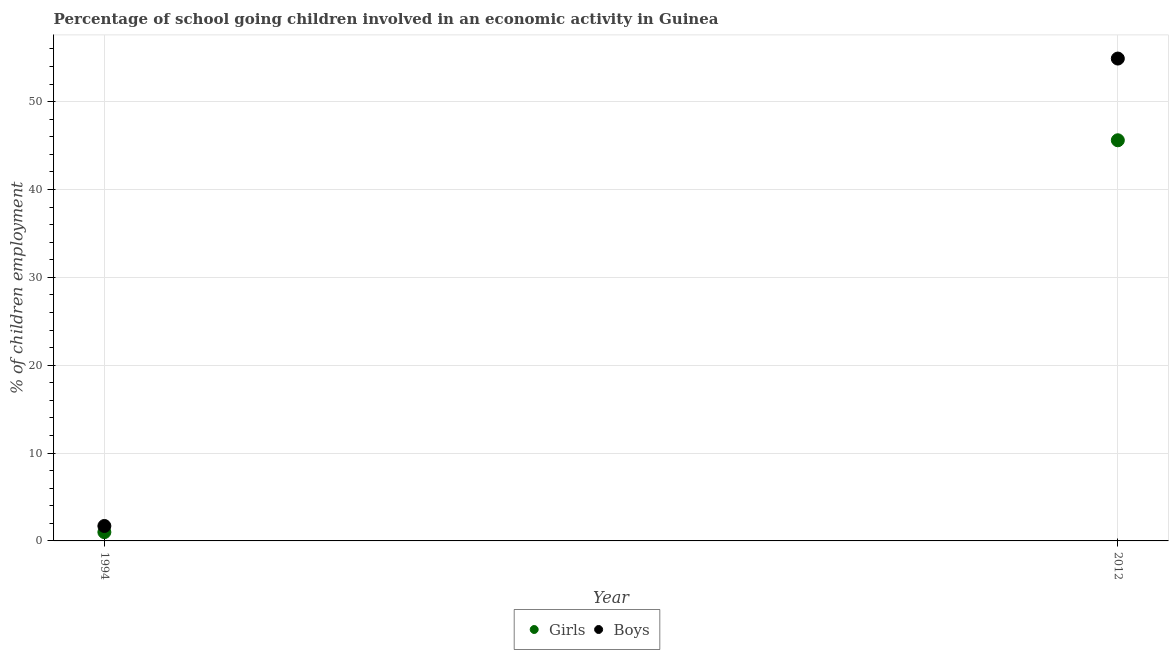What is the percentage of school going girls in 2012?
Provide a succinct answer. 45.6. Across all years, what is the maximum percentage of school going boys?
Offer a terse response. 54.9. In which year was the percentage of school going girls maximum?
Give a very brief answer. 2012. In which year was the percentage of school going girls minimum?
Your answer should be very brief. 1994. What is the total percentage of school going boys in the graph?
Your answer should be very brief. 56.6. What is the difference between the percentage of school going girls in 1994 and that in 2012?
Provide a short and direct response. -44.6. What is the difference between the percentage of school going girls in 1994 and the percentage of school going boys in 2012?
Keep it short and to the point. -53.9. What is the average percentage of school going boys per year?
Offer a very short reply. 28.3. In how many years, is the percentage of school going boys greater than 52 %?
Provide a succinct answer. 1. What is the ratio of the percentage of school going boys in 1994 to that in 2012?
Make the answer very short. 0.03. Is the percentage of school going girls in 1994 less than that in 2012?
Offer a very short reply. Yes. In how many years, is the percentage of school going boys greater than the average percentage of school going boys taken over all years?
Offer a terse response. 1. Does the percentage of school going girls monotonically increase over the years?
Ensure brevity in your answer.  Yes. Is the percentage of school going girls strictly less than the percentage of school going boys over the years?
Offer a very short reply. Yes. What is the difference between two consecutive major ticks on the Y-axis?
Provide a succinct answer. 10. Does the graph contain any zero values?
Make the answer very short. No. Where does the legend appear in the graph?
Your response must be concise. Bottom center. How many legend labels are there?
Give a very brief answer. 2. What is the title of the graph?
Ensure brevity in your answer.  Percentage of school going children involved in an economic activity in Guinea. What is the label or title of the Y-axis?
Provide a succinct answer. % of children employment. What is the % of children employment in Girls in 1994?
Your response must be concise. 1. What is the % of children employment in Boys in 1994?
Your answer should be compact. 1.7. What is the % of children employment in Girls in 2012?
Your response must be concise. 45.6. What is the % of children employment in Boys in 2012?
Your answer should be compact. 54.9. Across all years, what is the maximum % of children employment in Girls?
Your answer should be very brief. 45.6. Across all years, what is the maximum % of children employment in Boys?
Your response must be concise. 54.9. What is the total % of children employment in Girls in the graph?
Your answer should be very brief. 46.6. What is the total % of children employment in Boys in the graph?
Your answer should be very brief. 56.6. What is the difference between the % of children employment in Girls in 1994 and that in 2012?
Offer a very short reply. -44.6. What is the difference between the % of children employment in Boys in 1994 and that in 2012?
Keep it short and to the point. -53.2. What is the difference between the % of children employment in Girls in 1994 and the % of children employment in Boys in 2012?
Offer a very short reply. -53.9. What is the average % of children employment of Girls per year?
Provide a short and direct response. 23.3. What is the average % of children employment of Boys per year?
Make the answer very short. 28.3. In the year 1994, what is the difference between the % of children employment of Girls and % of children employment of Boys?
Ensure brevity in your answer.  -0.7. In the year 2012, what is the difference between the % of children employment in Girls and % of children employment in Boys?
Provide a succinct answer. -9.3. What is the ratio of the % of children employment of Girls in 1994 to that in 2012?
Keep it short and to the point. 0.02. What is the ratio of the % of children employment in Boys in 1994 to that in 2012?
Give a very brief answer. 0.03. What is the difference between the highest and the second highest % of children employment of Girls?
Offer a terse response. 44.6. What is the difference between the highest and the second highest % of children employment of Boys?
Provide a short and direct response. 53.2. What is the difference between the highest and the lowest % of children employment of Girls?
Your response must be concise. 44.6. What is the difference between the highest and the lowest % of children employment in Boys?
Offer a terse response. 53.2. 